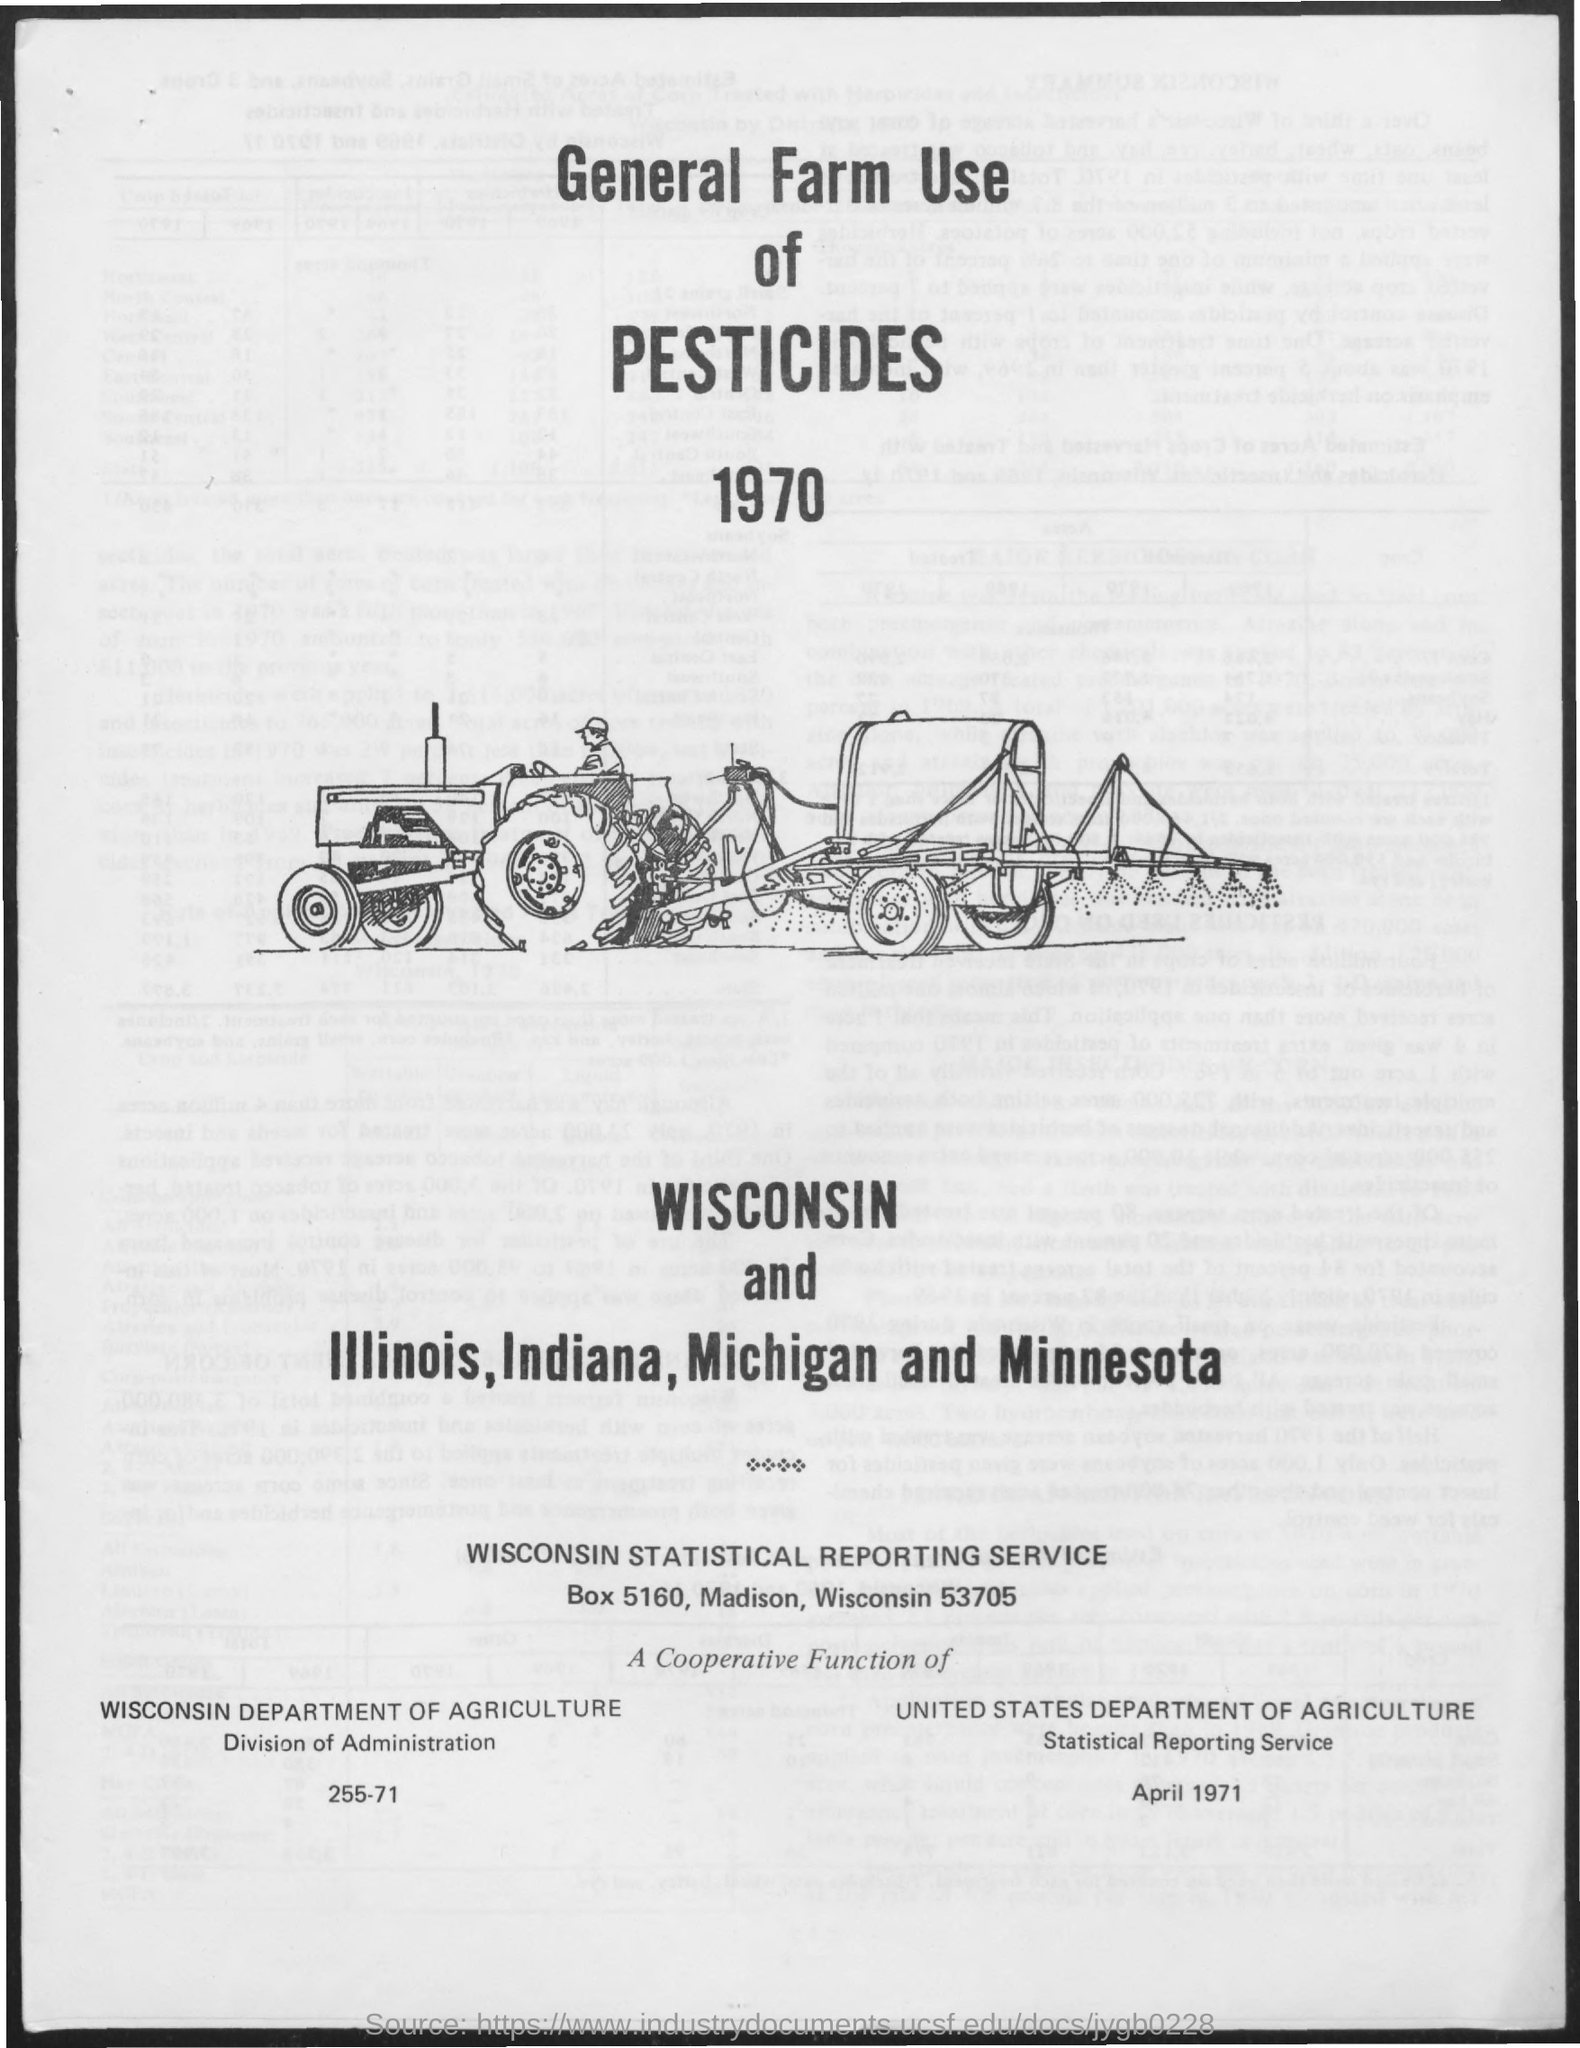Identify some key points in this picture. The title of the document is "General Farm Use of Pesticides in 1970. 